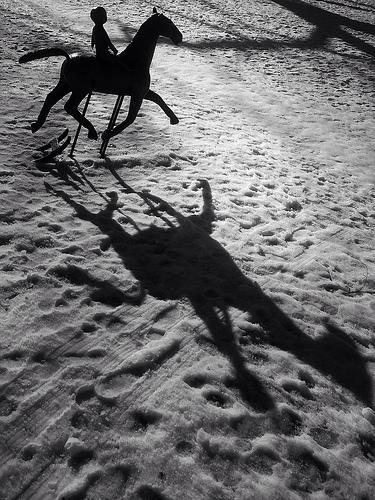Question: what is on the ground?
Choices:
A. Ice.
B. Grass.
C. Rocks.
D. Snow.
Answer with the letter. Answer: D Question: what is the baby doll doing?
Choices:
A. Sleeping.
B. Drinking a bottle.
C. Riding the horse.
D. Crying.
Answer with the letter. Answer: C Question: who is on top of the horse?
Choices:
A. A little girl.
B. A woman.
C. A man.
D. A baby doll.
Answer with the letter. Answer: D Question: what is the baby doll riding?
Choices:
A. A bike.
B. A wagon.
C. A donkey.
D. A horse.
Answer with the letter. Answer: D 